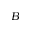<formula> <loc_0><loc_0><loc_500><loc_500>B</formula> 